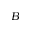<formula> <loc_0><loc_0><loc_500><loc_500>B</formula> 